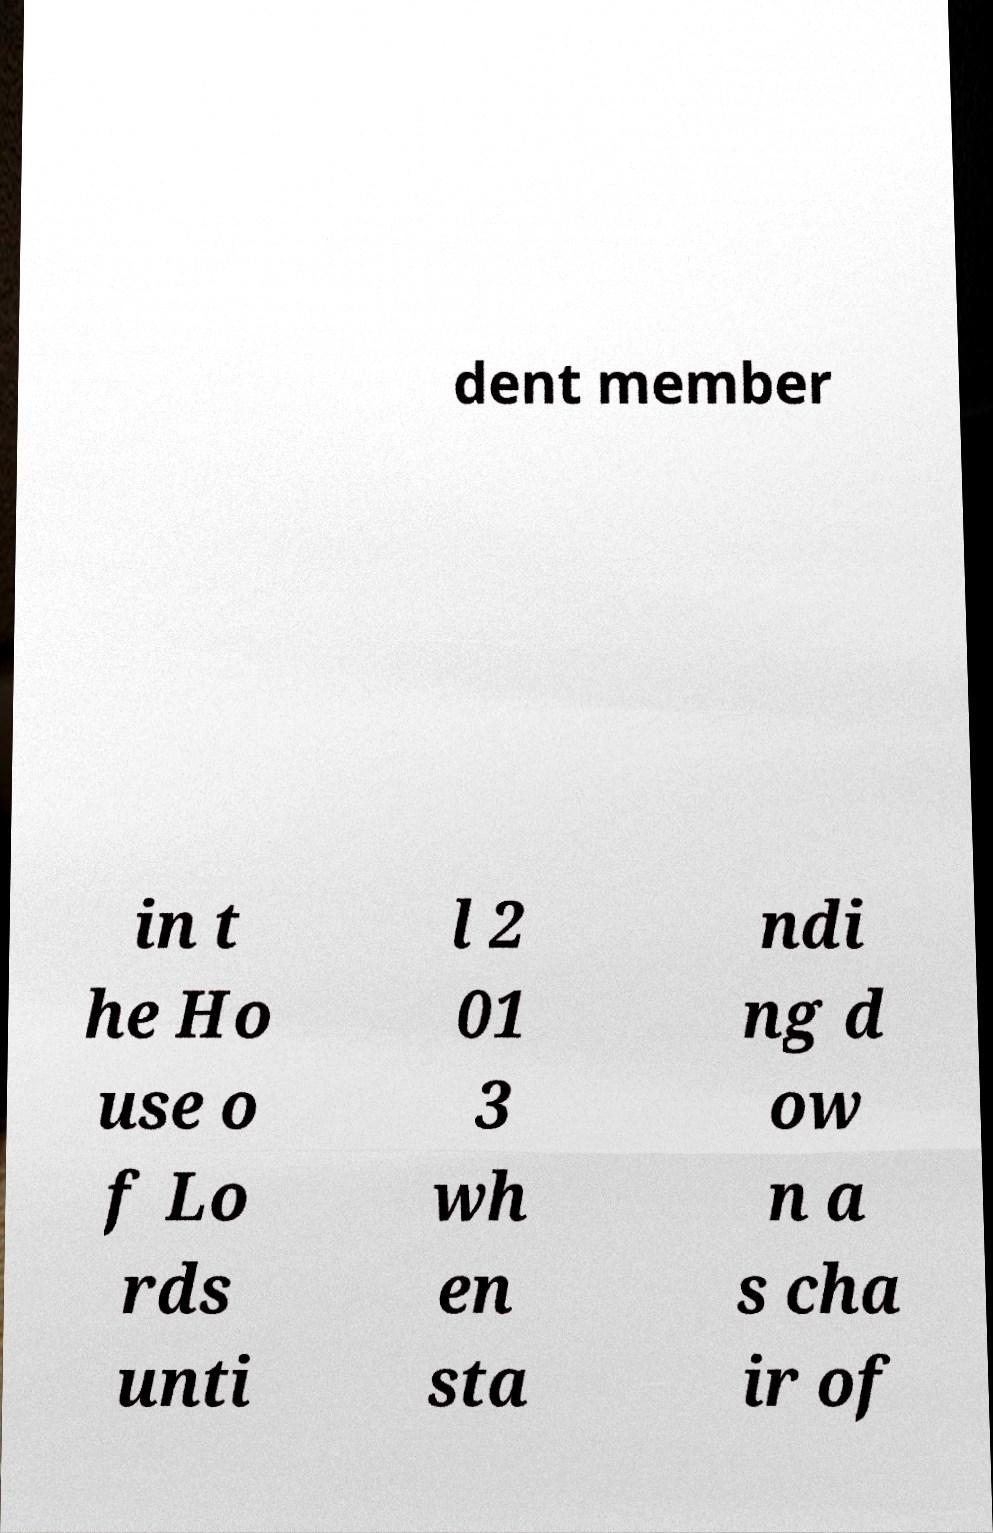Can you read and provide the text displayed in the image?This photo seems to have some interesting text. Can you extract and type it out for me? dent member in t he Ho use o f Lo rds unti l 2 01 3 wh en sta ndi ng d ow n a s cha ir of 